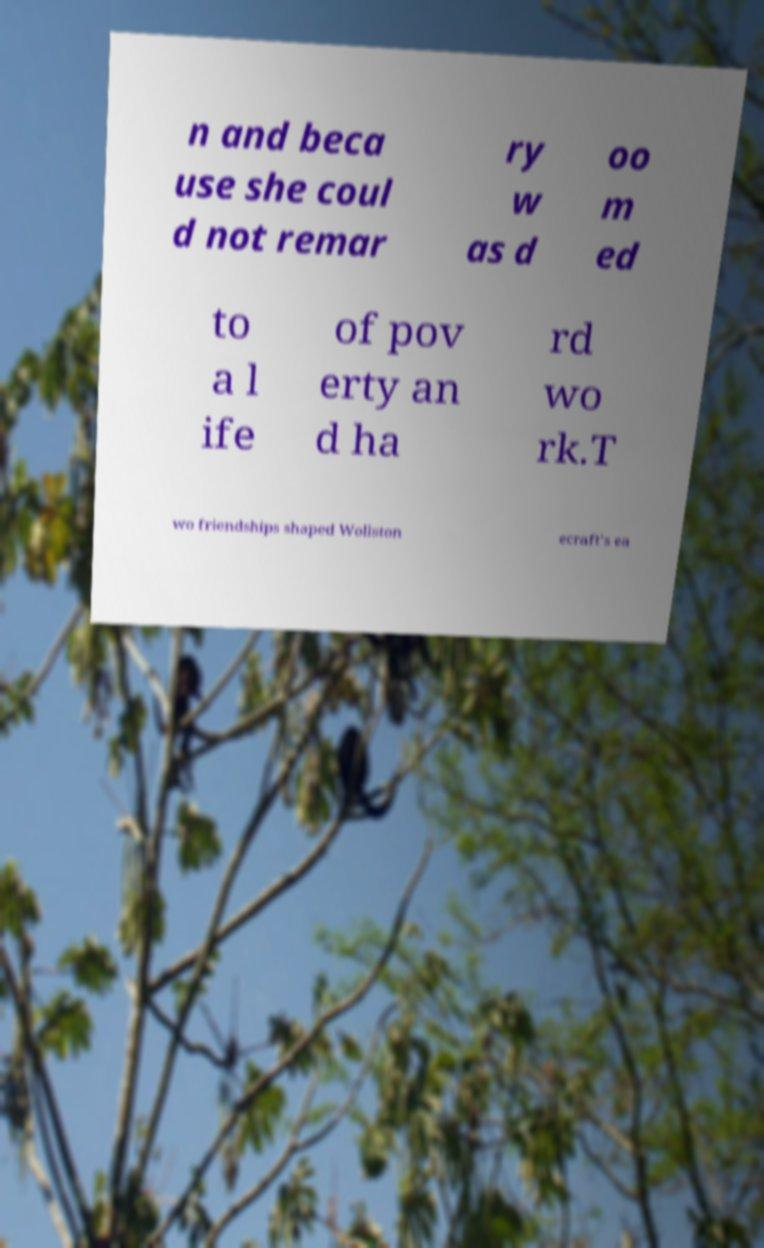Please read and relay the text visible in this image. What does it say? n and beca use she coul d not remar ry w as d oo m ed to a l ife of pov erty an d ha rd wo rk.T wo friendships shaped Wollston ecraft's ea 